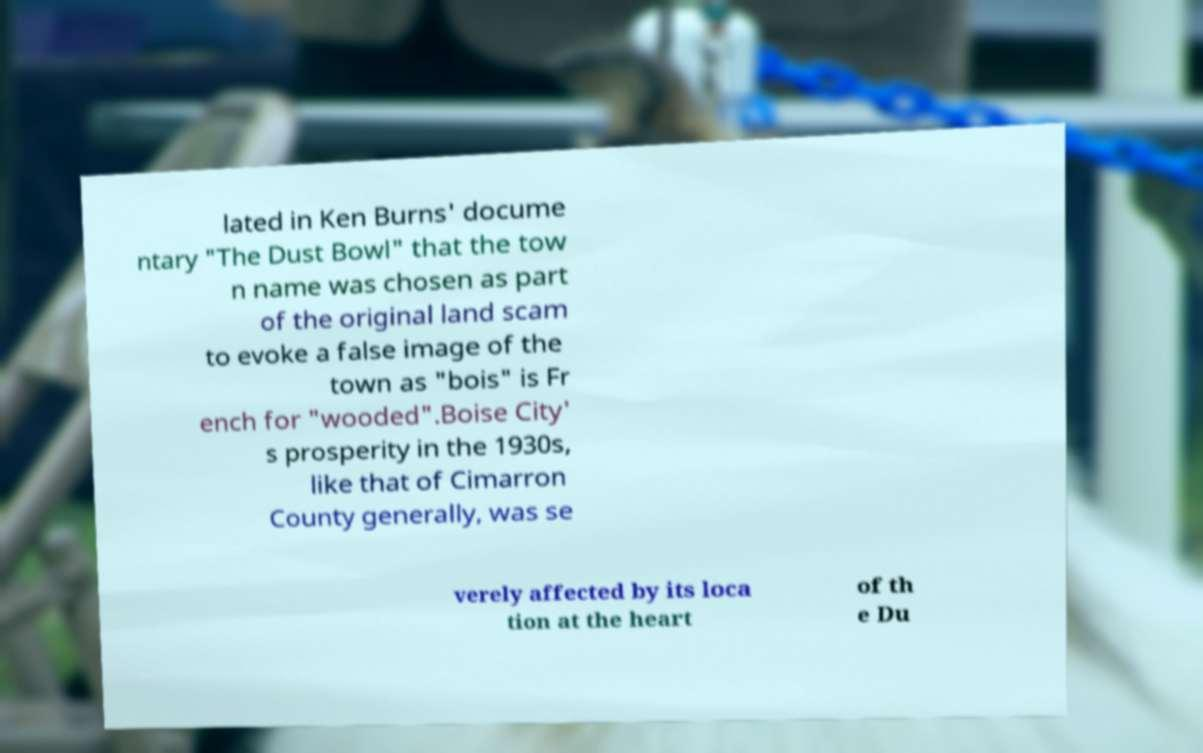I need the written content from this picture converted into text. Can you do that? lated in Ken Burns' docume ntary "The Dust Bowl" that the tow n name was chosen as part of the original land scam to evoke a false image of the town as "bois" is Fr ench for "wooded".Boise City' s prosperity in the 1930s, like that of Cimarron County generally, was se verely affected by its loca tion at the heart of th e Du 